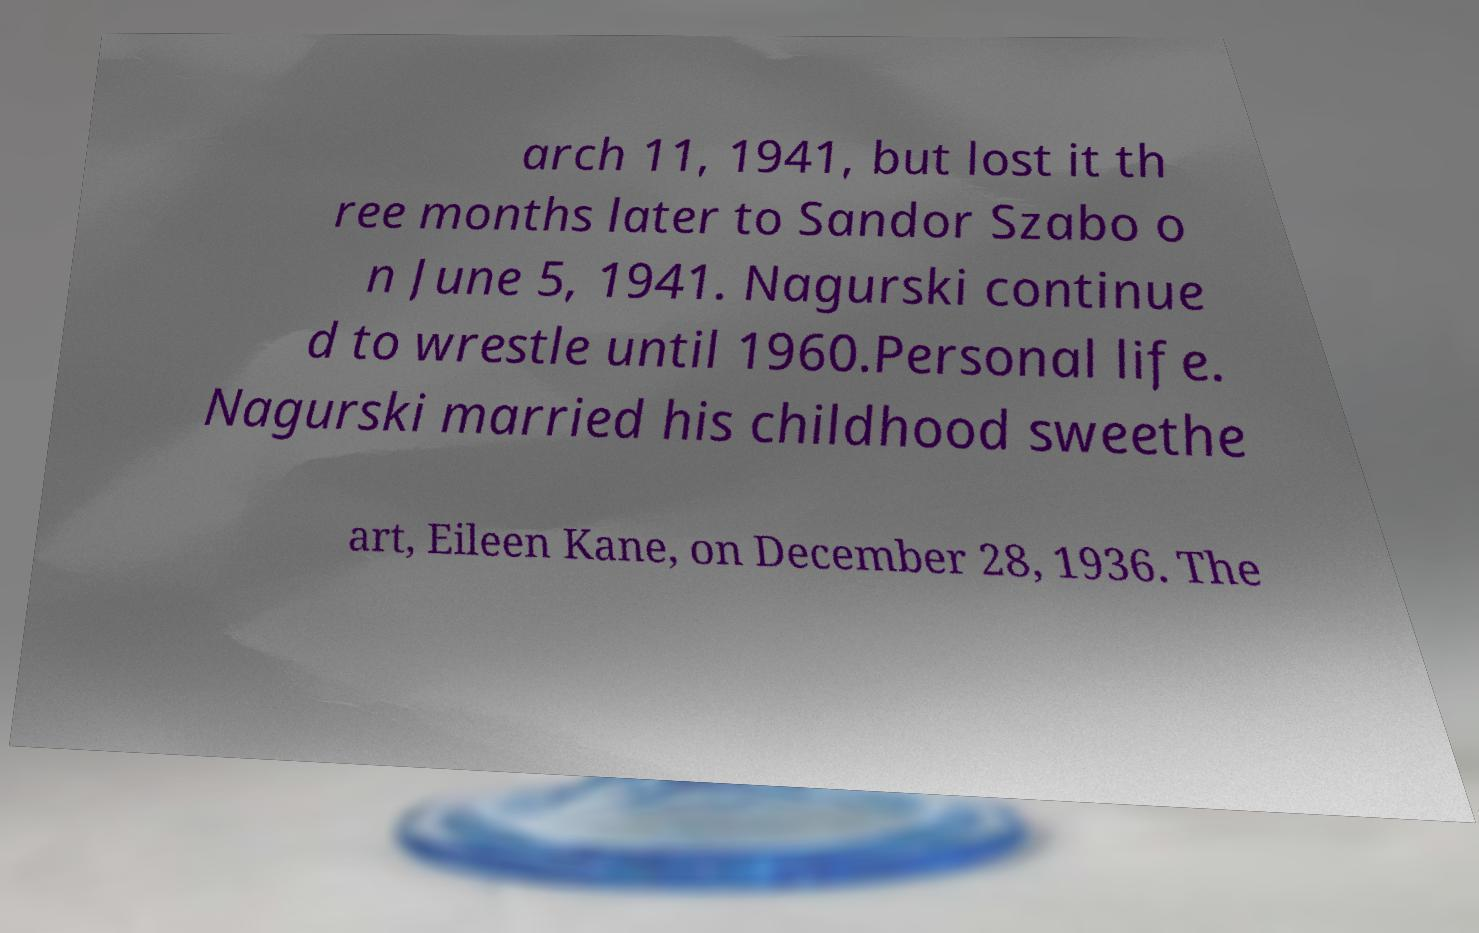Can you accurately transcribe the text from the provided image for me? arch 11, 1941, but lost it th ree months later to Sandor Szabo o n June 5, 1941. Nagurski continue d to wrestle until 1960.Personal life. Nagurski married his childhood sweethe art, Eileen Kane, on December 28, 1936. The 